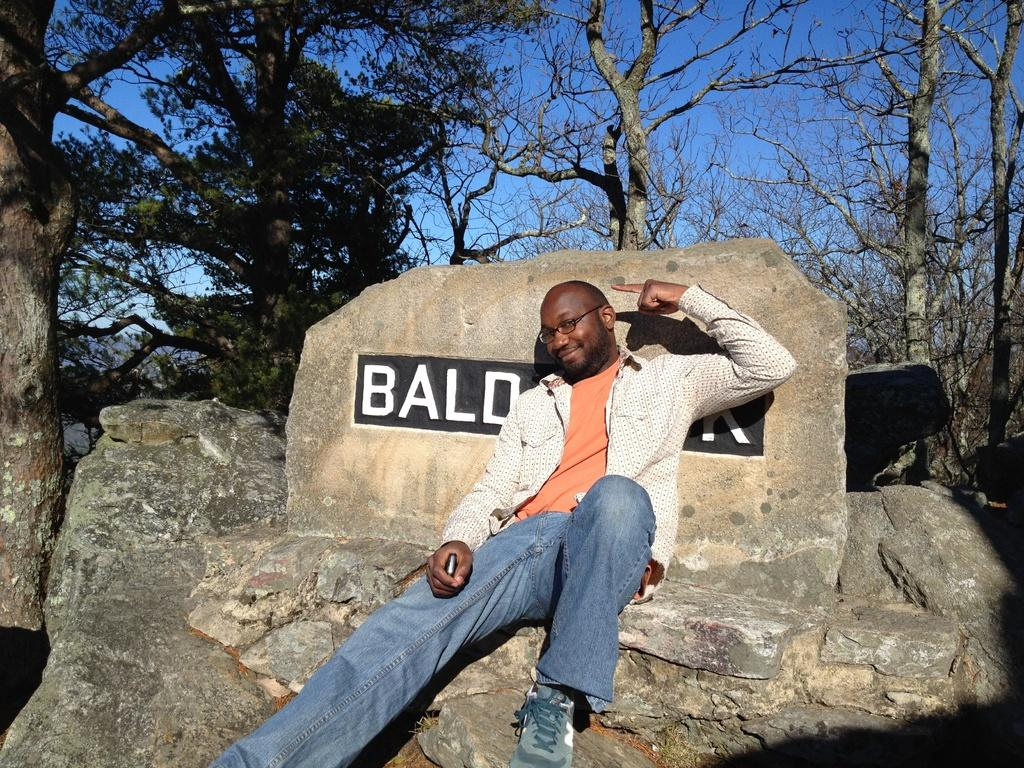Who is the main subject in the image? There is a man in the image. What is the man sitting on? The man is sitting on a chair-shaped rock. Who is the man looking at? The man is looking at someone. What can be seen in the background of the image? There are trees and a blue sky in the background of the image. What invention is the man holding in his hand in the image? There is no invention visible in the man's hand in the image. What type of pen is the man using to sign the agreement in the image? There is no pen or agreement present in the image. 